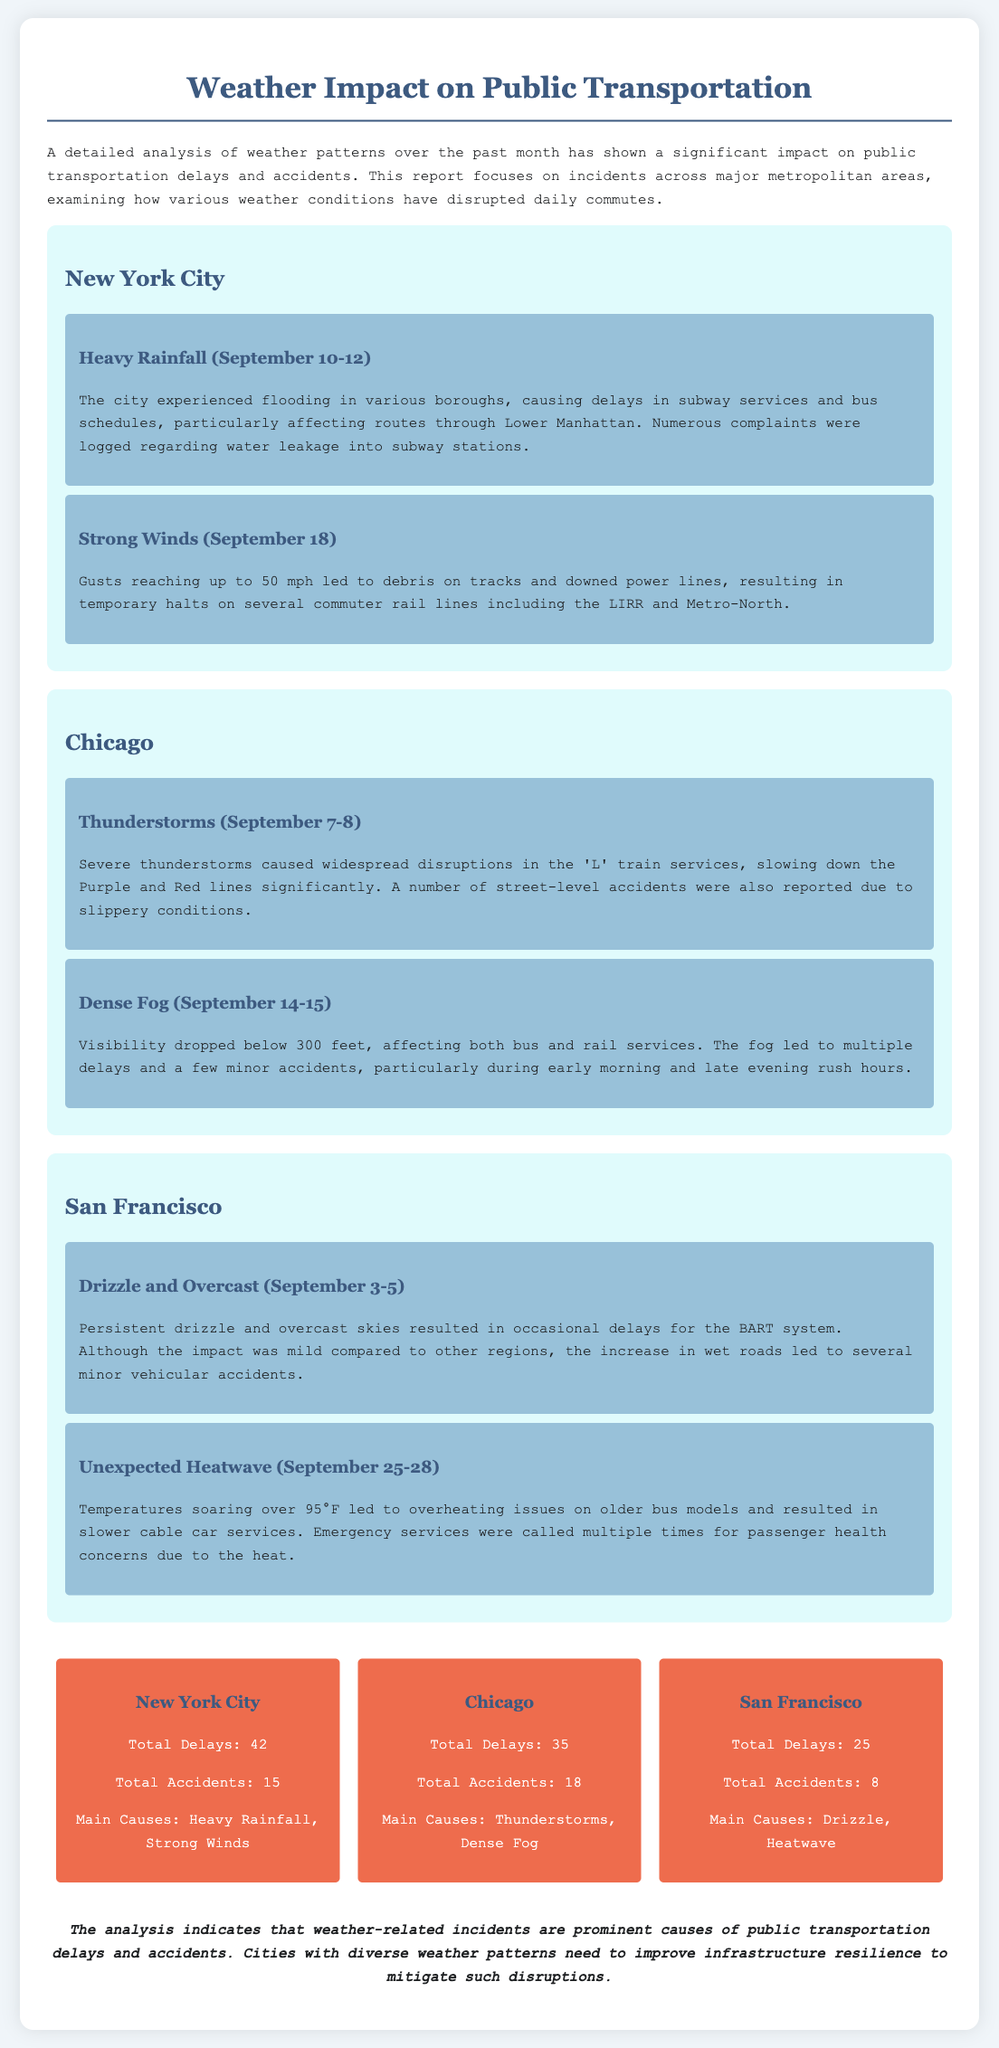What was the total number of delays in New York City? The total delays for New York City are listed as 42 in the statistics section of the document.
Answer: 42 What caused the accidents in Chicago? The main causes for accidents in Chicago were thunderstorms and dense fog, as described in the corresponding events.
Answer: Thunderstorms, Dense Fog How many accidents were reported in San Francisco? The document states that the total accidents in San Francisco were 8.
Answer: 8 What weather condition affected subway services in New York City? Heavy rainfall caused flooding that impacted subway services, as detailed in the events for New York City.
Answer: Heavy Rainfall What is the average number of delays across all three cities? The total delays are added (42 for NYC, 35 for Chicago, 25 for SF) resulting in 102. Divided by three gives an average of 34.
Answer: 34 What weather condition occurred in San Francisco from September 25-28? The unexpected heatwave is specifically noted as the event occurring during that time in San Francisco.
Answer: Unexpected Heatwave How many total accidents happened in New York City? The report indicates that New York City experienced a total of 15 accidents.
Answer: 15 